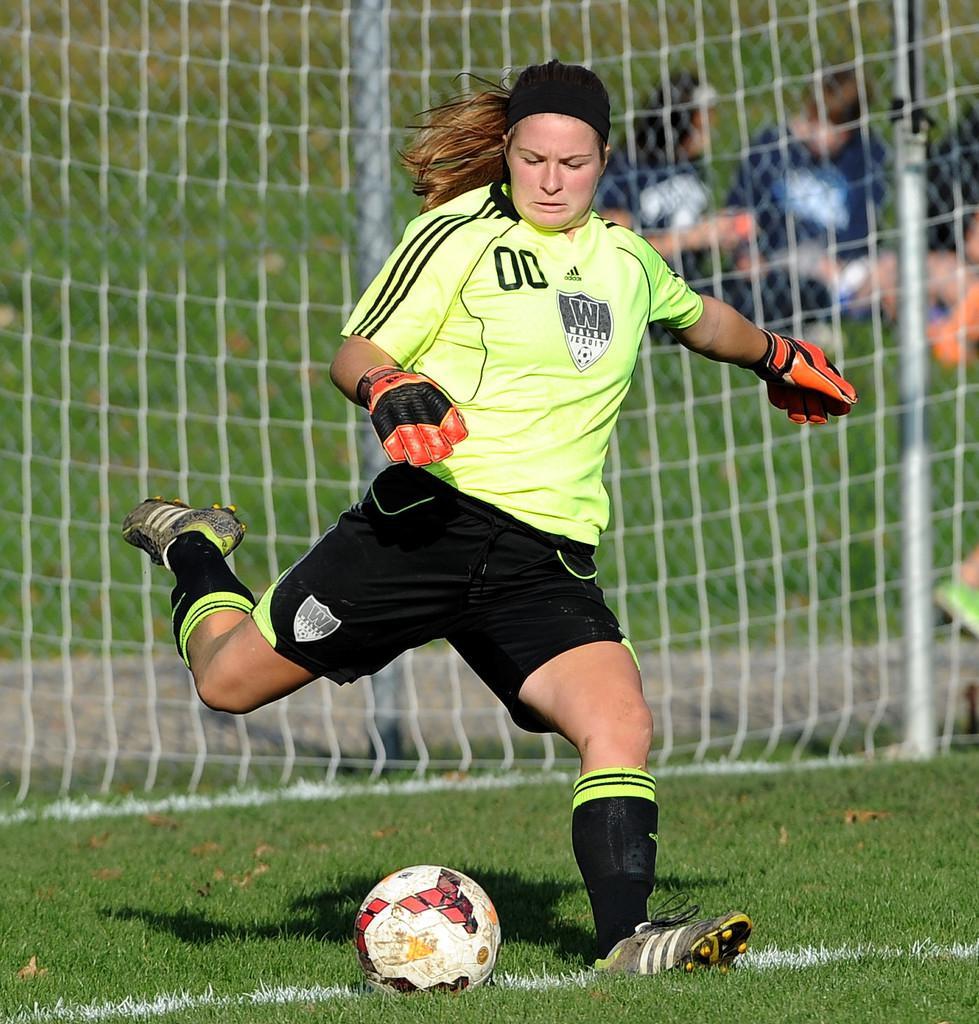Describe this image in one or two sentences. In the foreground picture we can see a woman kicking a football. In the foreground there is grass. In the middle there is goal post. The background is blurred. In the background we can see greenery and some blue color objects. 